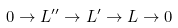<formula> <loc_0><loc_0><loc_500><loc_500>0 \to L ^ { \prime \prime } \to L ^ { \prime } \to L \to 0</formula> 